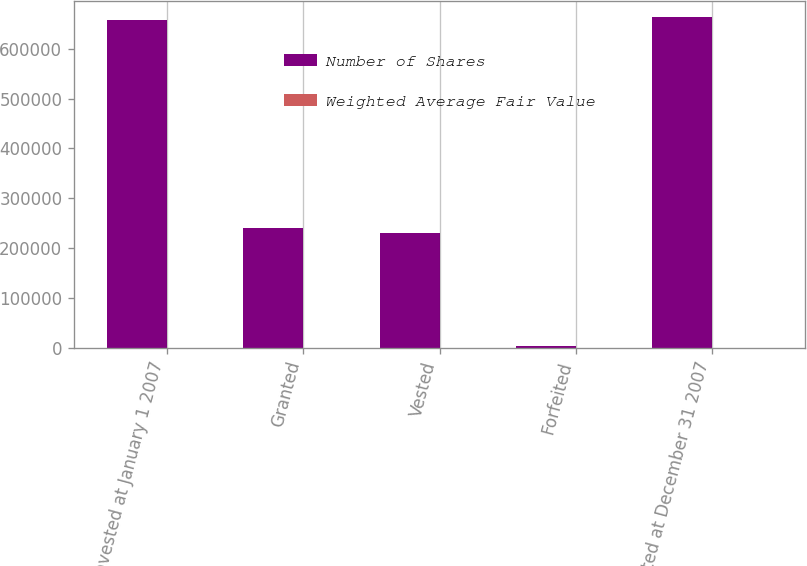Convert chart. <chart><loc_0><loc_0><loc_500><loc_500><stacked_bar_chart><ecel><fcel>Nonvested at January 1 2007<fcel>Granted<fcel>Vested<fcel>Forfeited<fcel>Nonvested at December 31 2007<nl><fcel>Number of Shares<fcel>657000<fcel>240000<fcel>231000<fcel>3000<fcel>663000<nl><fcel>Weighted Average Fair Value<fcel>38.18<fcel>52.63<fcel>38.8<fcel>51.37<fcel>43.13<nl></chart> 